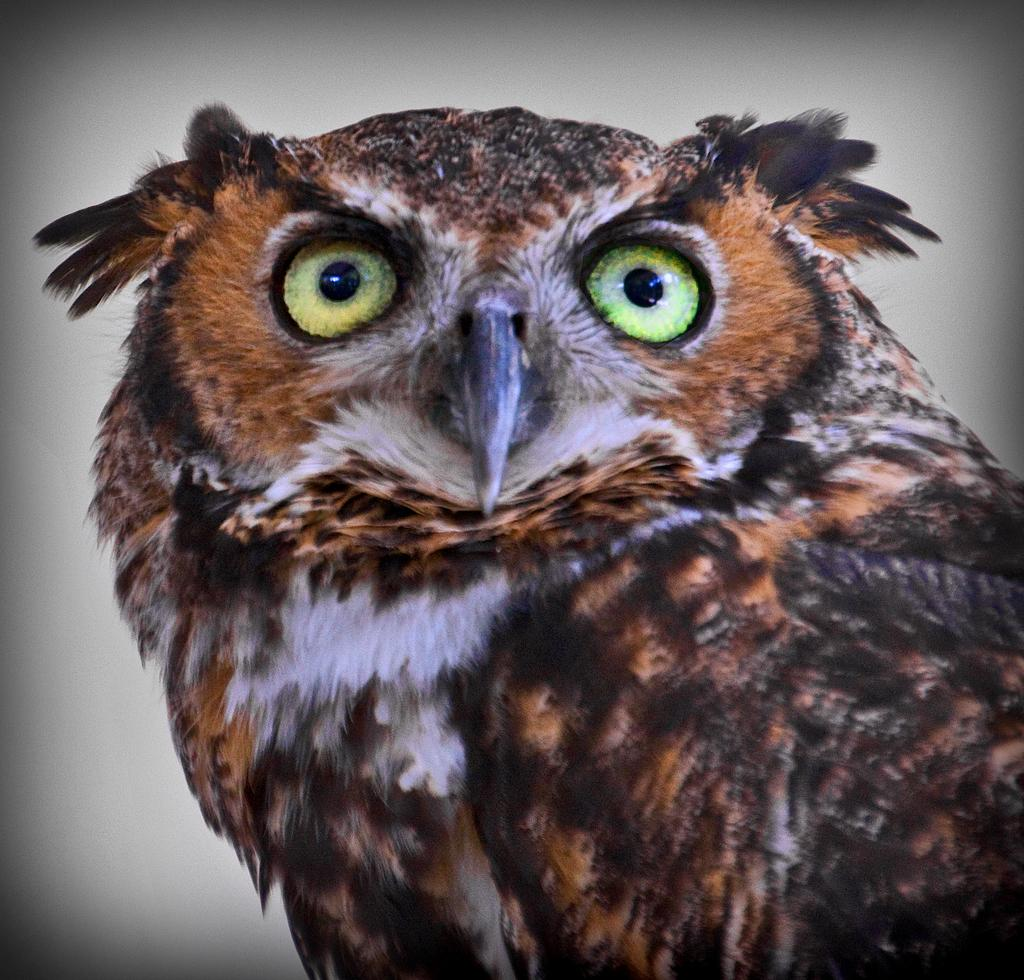What type of animal is in the image? There is an owl in the image. What colors can be seen on the owl? The owl has brown, black, and white colors. What is the color of the background in the image? The background of the image is white. What song is the owl singing in the image? Owls do not sing songs, so there is no song being sung by the owl in the image. What type of lipstick is the owl wearing in the image? Owls do not wear lipstick, so there is no lipstick present in the image. 